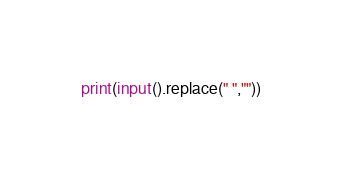Convert code to text. <code><loc_0><loc_0><loc_500><loc_500><_Python_>print(input().replace(" ",""))
</code> 